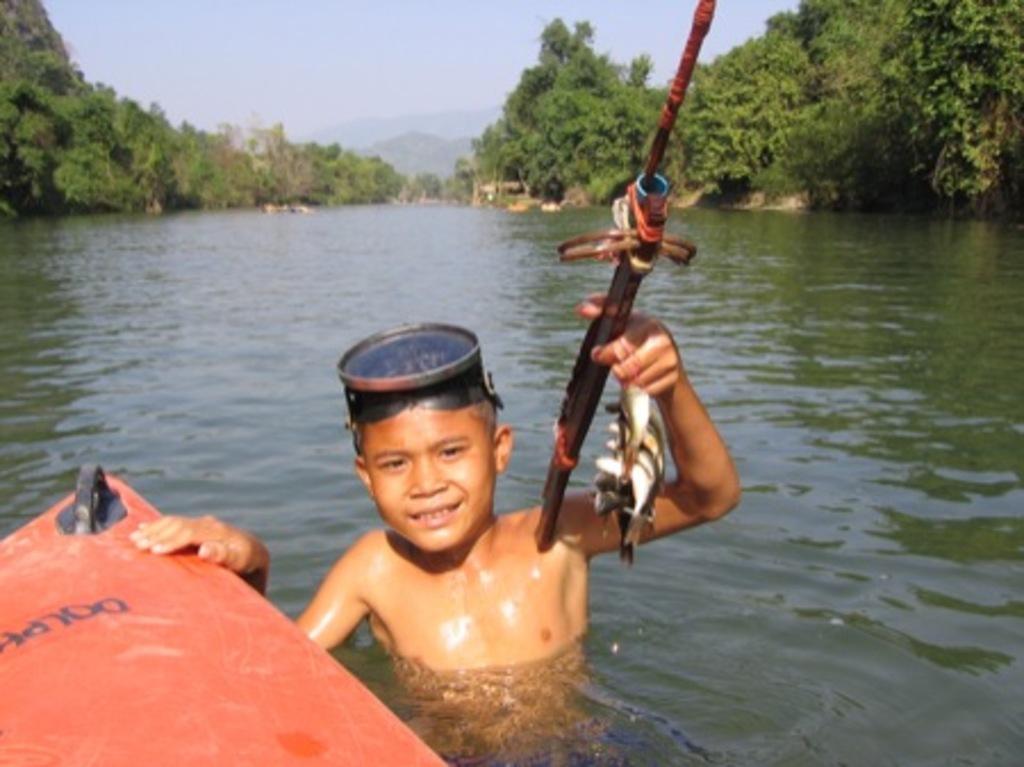Could you give a brief overview of what you see in this image? This picture is clicked outside the city. On the left there is a red color object seems to be a boat and we can see a kid in the water body holding an object. In the background there is a sky and trees. 